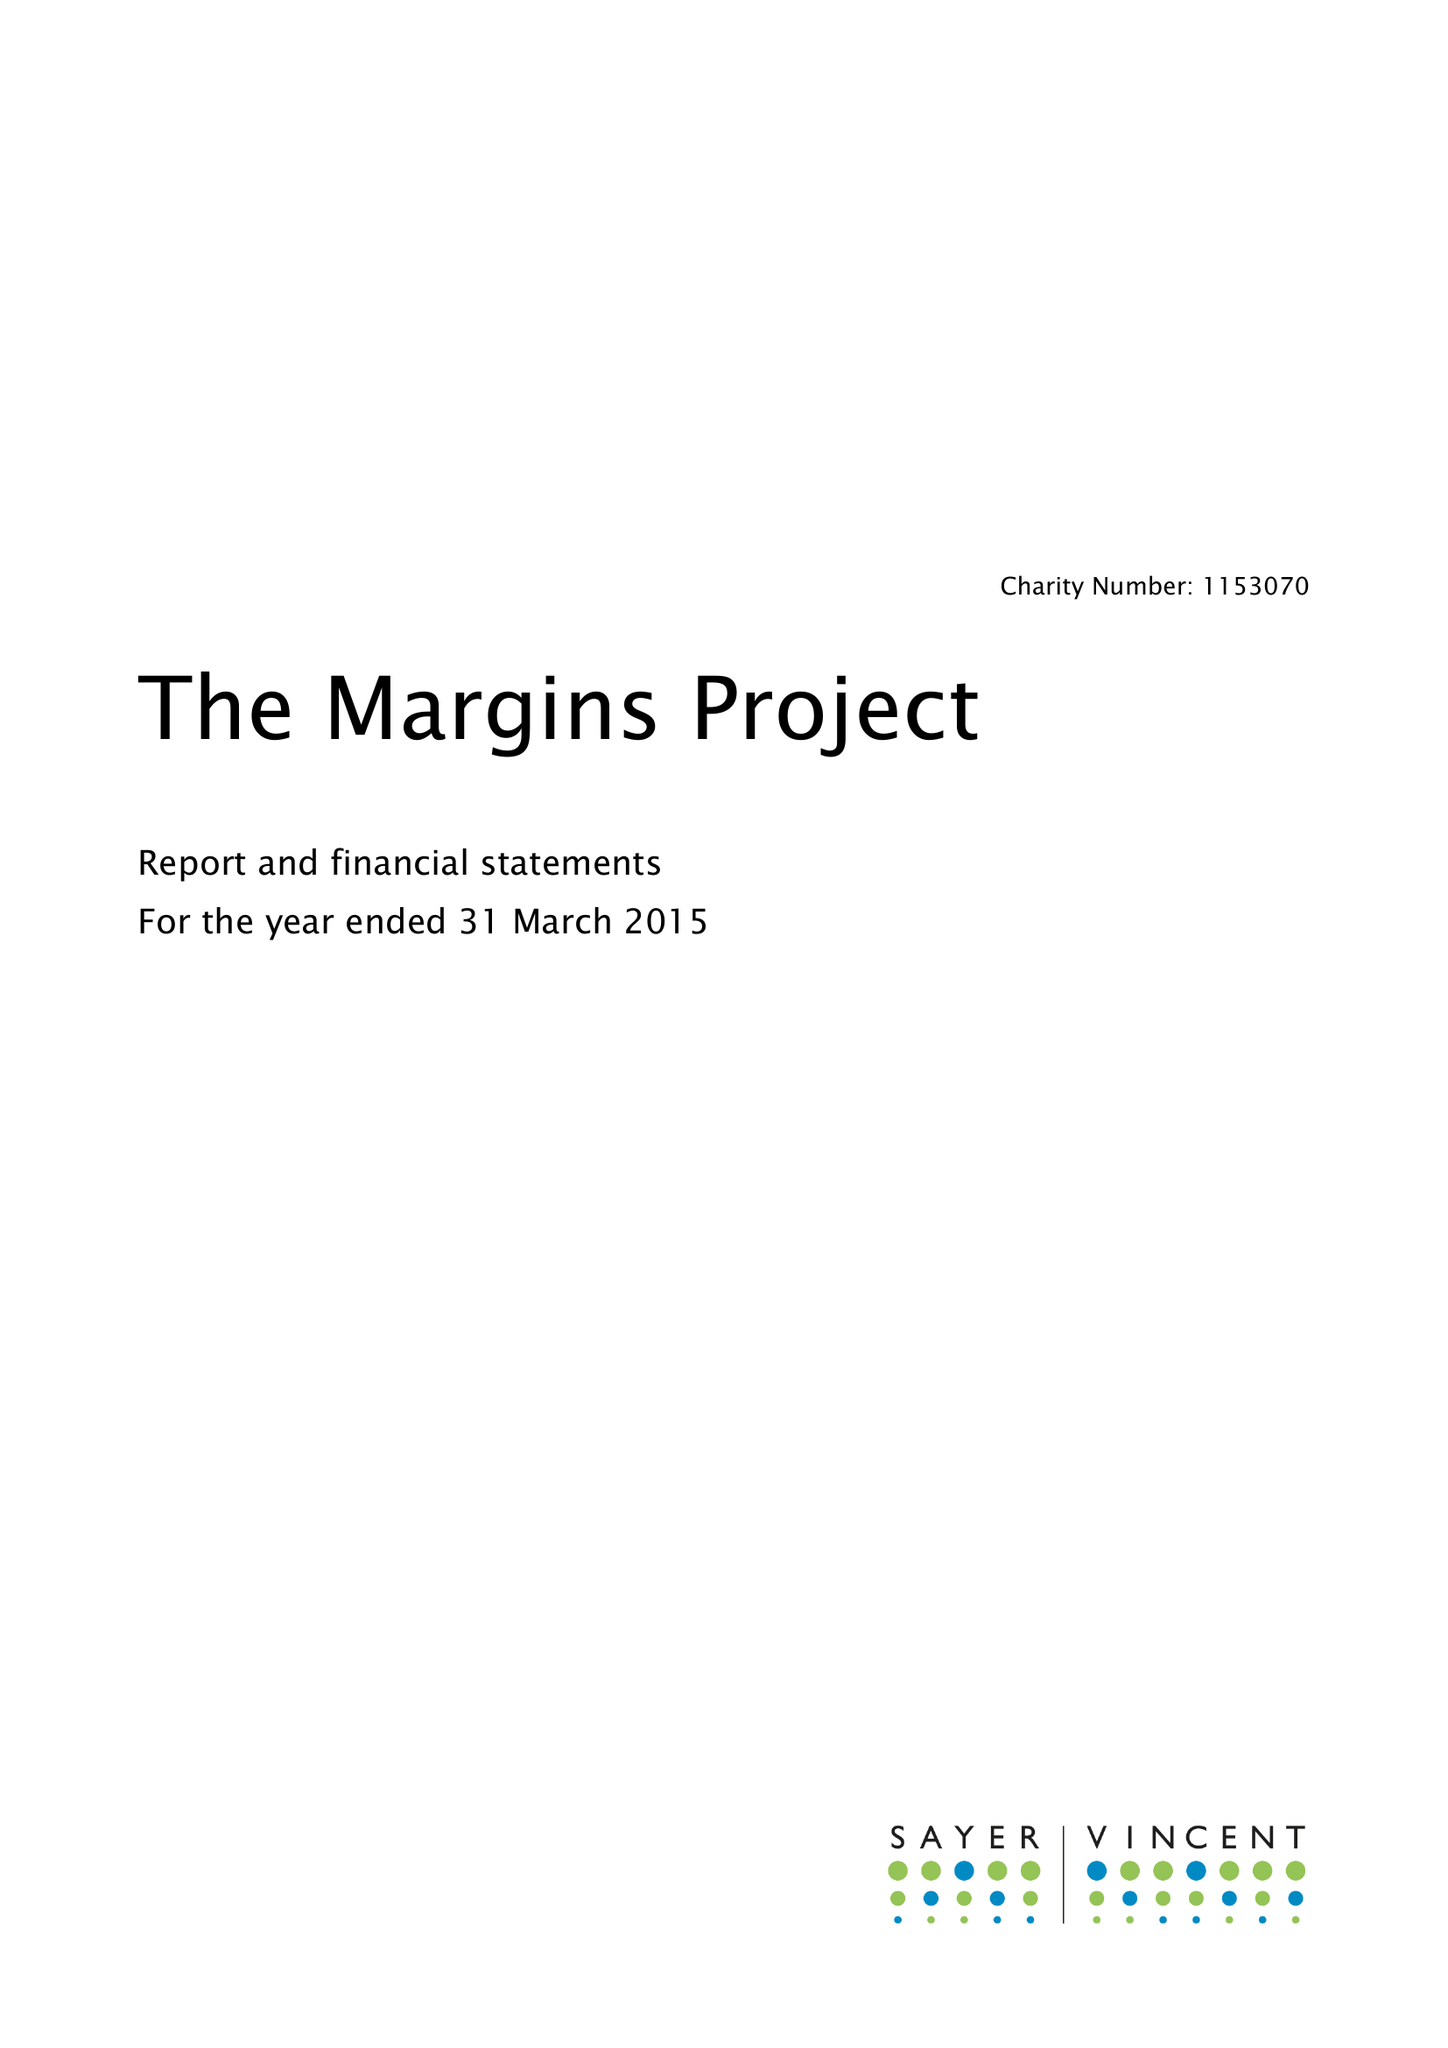What is the value for the spending_annually_in_british_pounds?
Answer the question using a single word or phrase. 148672.00 